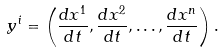Convert formula to latex. <formula><loc_0><loc_0><loc_500><loc_500>y ^ { i } = \left ( \frac { d x ^ { 1 } } { d t } , \frac { d x ^ { 2 } } { d t } , \dots , \frac { d x ^ { n } } { d t } \right ) .</formula> 